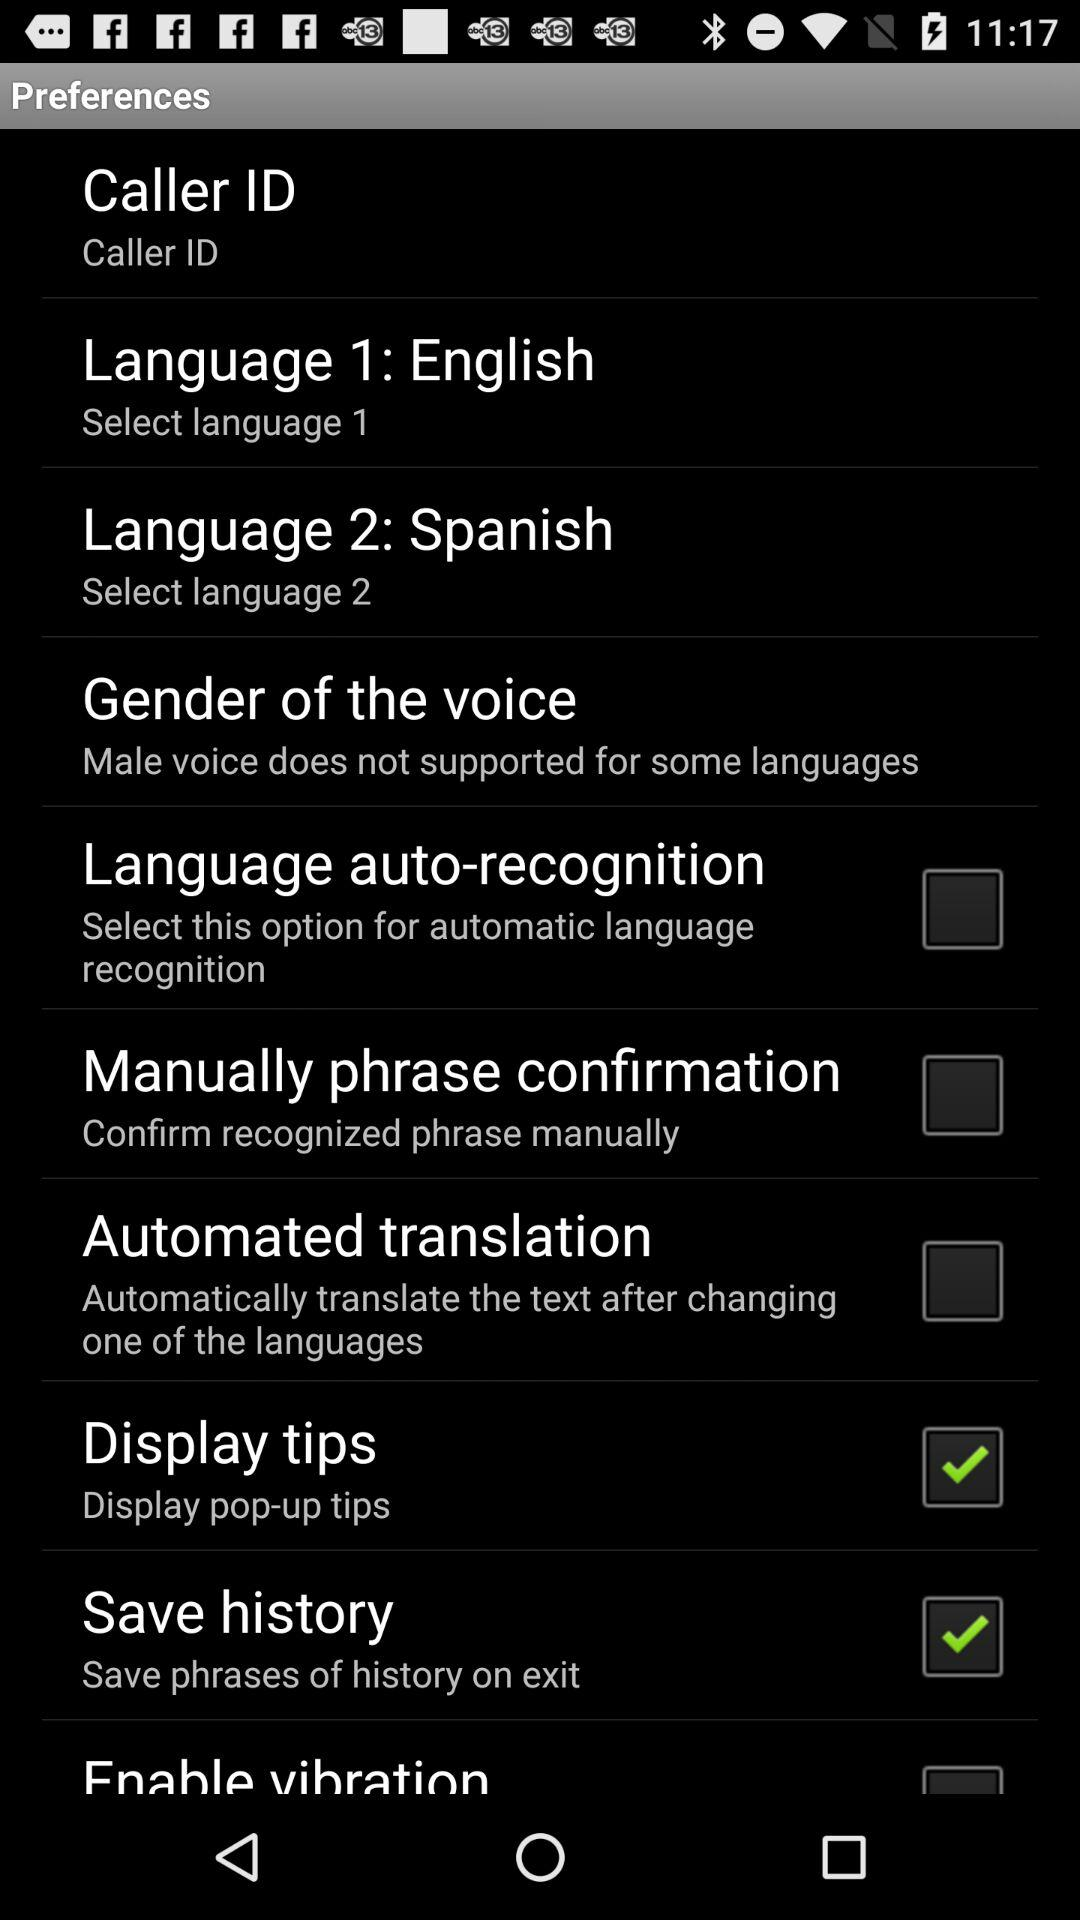What is the status of "Language auto-recognition"? The status of "Language auto-recognition" is "off". 